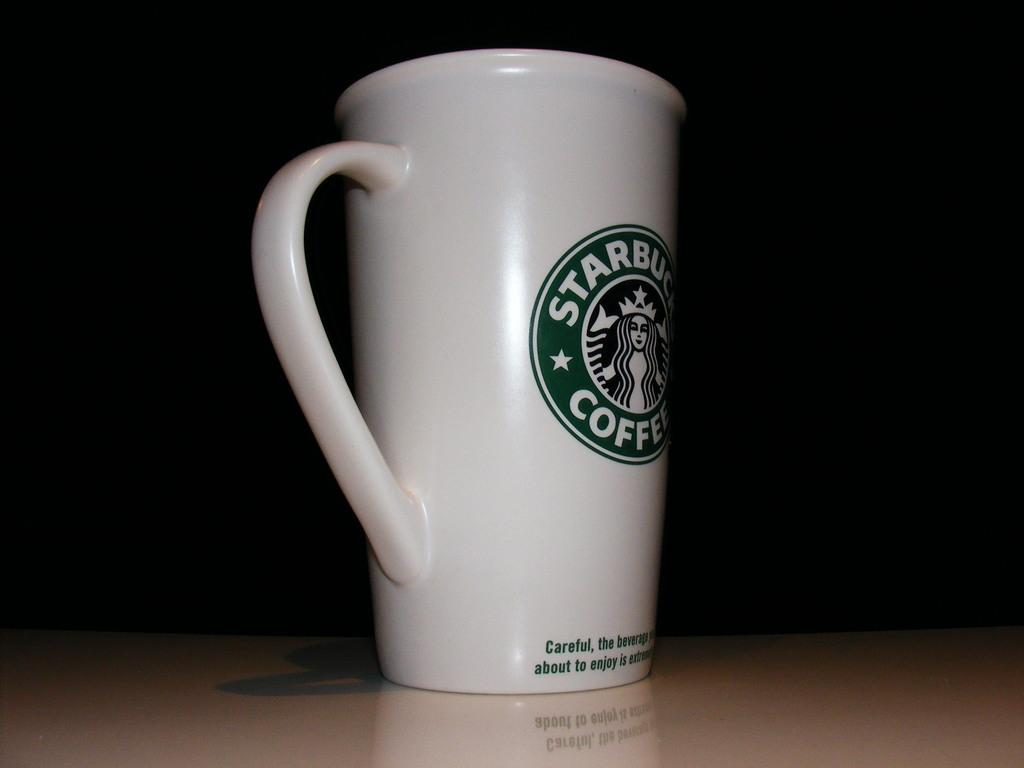<image>
Share a concise interpretation of the image provided. A tall ceramic cup that is from starbucks and made for coffee 